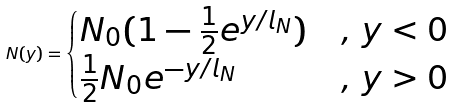<formula> <loc_0><loc_0><loc_500><loc_500>N ( y ) = \begin{cases} N _ { 0 } ( 1 - \frac { 1 } { 2 } e ^ { y / l _ { N } } ) & , \, y < 0 \\ \frac { 1 } { 2 } N _ { 0 } e ^ { - y / l _ { N } } & , \, y > 0 \end{cases}</formula> 